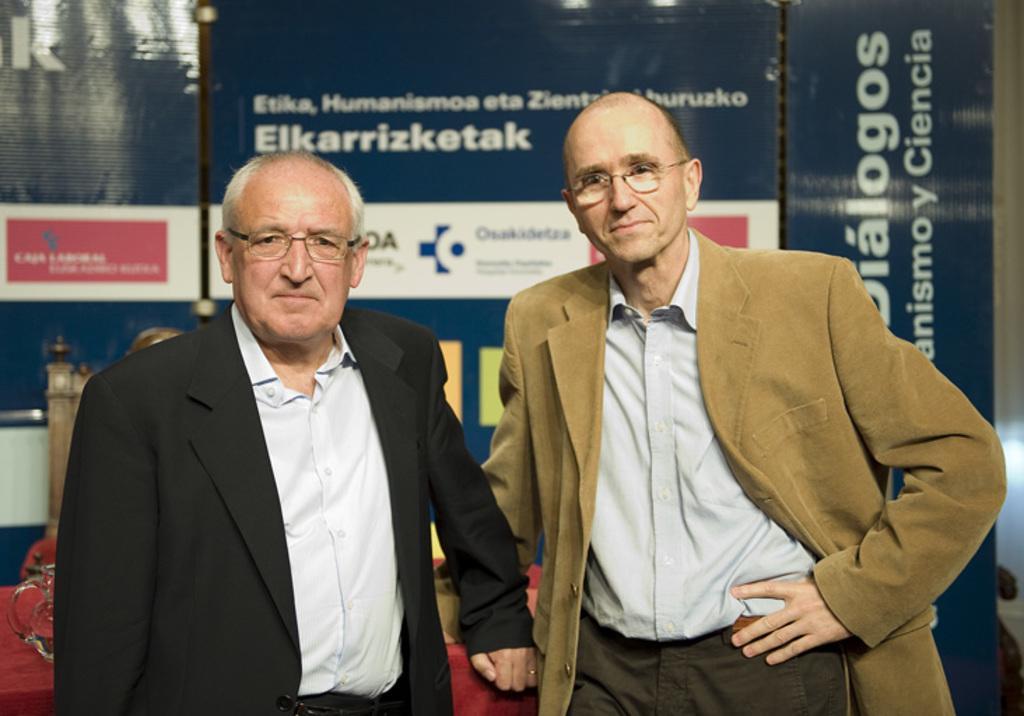In one or two sentences, can you explain what this image depicts? In this picture we can see two men are standing in the front, they are wearing spectacles, in the background there are words, we can see some text on these boards. 